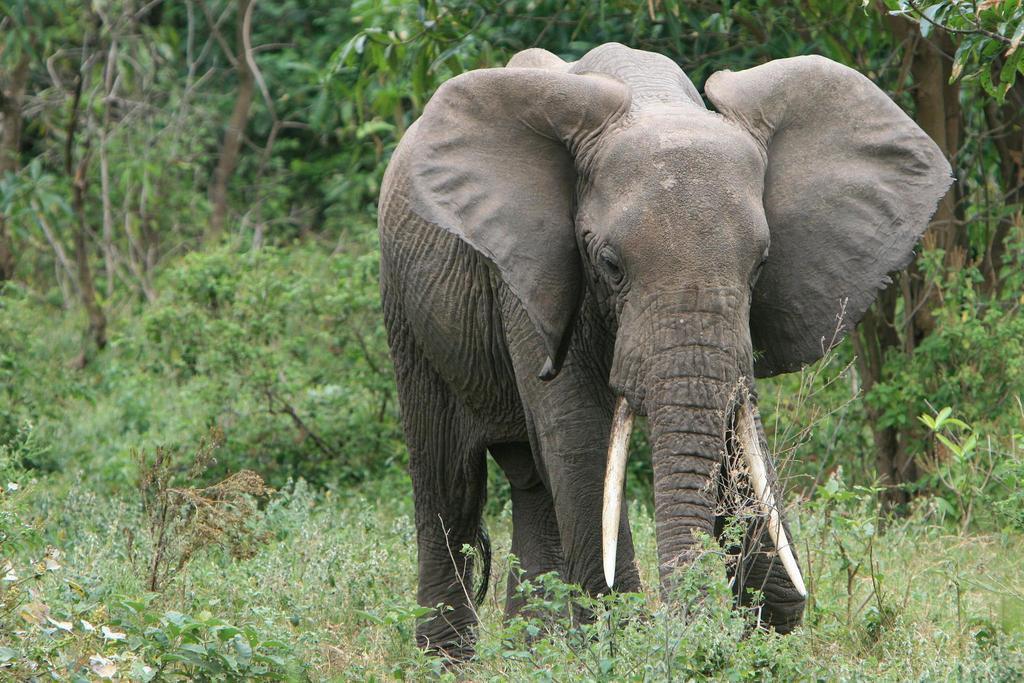Could you give a brief overview of what you see in this image? In this image we can see an elephant standing on the ground. In the background there are trees and plants. 